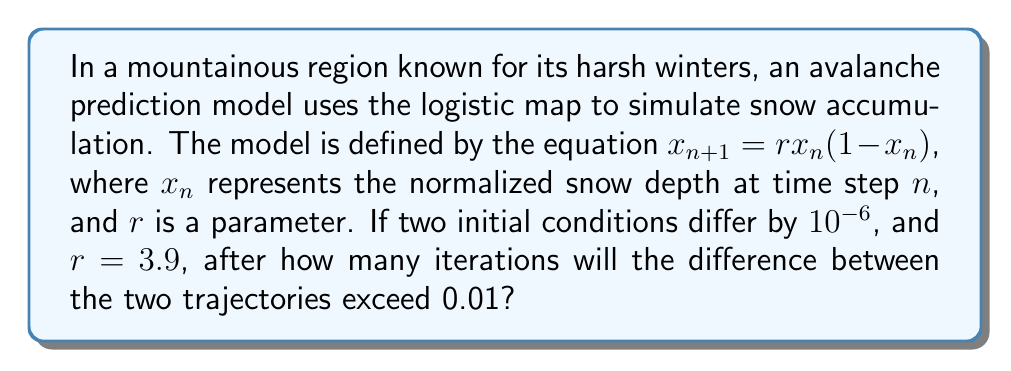Solve this math problem. To solve this problem, we'll use the concept of Lyapunov exponent, which measures the rate of divergence of nearby trajectories in a chaotic system.

1. The Lyapunov exponent for the logistic map is given by:
   $$\lambda = \lim_{n \to \infty} \frac{1}{n} \sum_{i=0}^{n-1} \ln|r(1-2x_i)|$$

2. For $r = 3.9$, we can approximate $\lambda \approx 0.6946$.

3. The divergence of two nearby trajectories can be estimated by:
   $$d_n \approx d_0 e^{\lambda n}$$
   where $d_0$ is the initial separation and $d_n$ is the separation after $n$ iterations.

4. We want to find $n$ when $d_n = 0.01$, given $d_0 = 10^{-6}$:
   $$0.01 \approx 10^{-6} e^{0.6946n}$$

5. Taking the natural logarithm of both sides:
   $$\ln(0.01) \approx \ln(10^{-6}) + 0.6946n$$

6. Solving for $n$:
   $$n \approx \frac{\ln(0.01) - \ln(10^{-6})}{0.6946} \approx 16.85$$

7. Since we need an integer number of iterations, we round up to the next whole number.
Answer: 17 iterations 